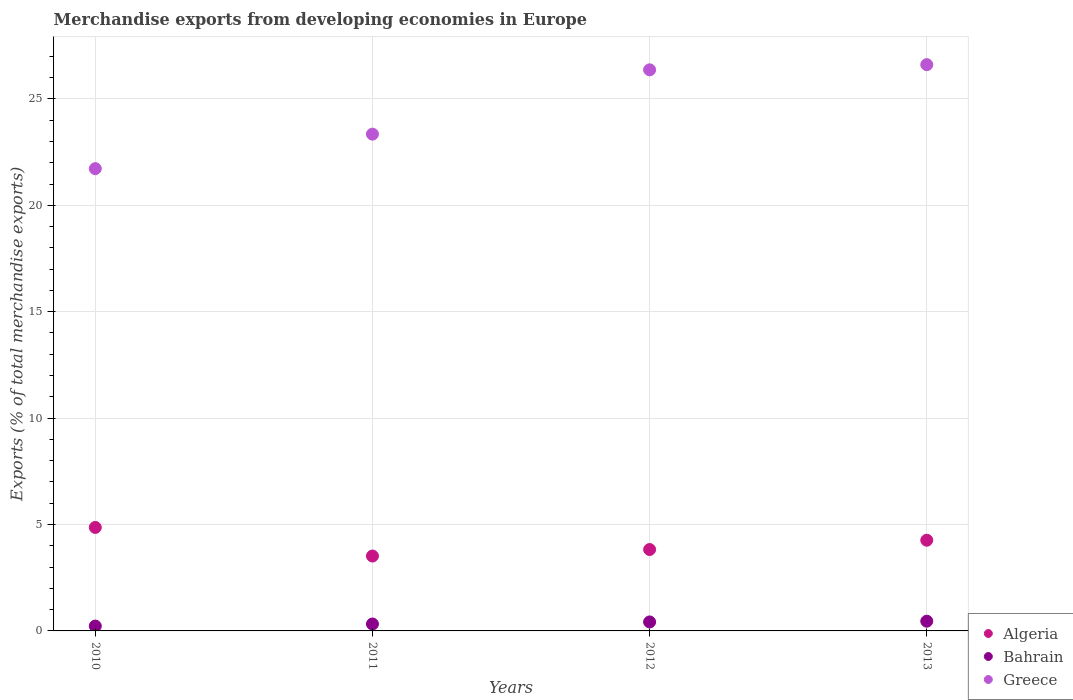How many different coloured dotlines are there?
Keep it short and to the point. 3. Is the number of dotlines equal to the number of legend labels?
Provide a succinct answer. Yes. What is the percentage of total merchandise exports in Greece in 2010?
Ensure brevity in your answer.  21.72. Across all years, what is the maximum percentage of total merchandise exports in Algeria?
Your response must be concise. 4.86. Across all years, what is the minimum percentage of total merchandise exports in Greece?
Provide a succinct answer. 21.72. In which year was the percentage of total merchandise exports in Greece maximum?
Offer a terse response. 2013. In which year was the percentage of total merchandise exports in Bahrain minimum?
Make the answer very short. 2010. What is the total percentage of total merchandise exports in Greece in the graph?
Your answer should be very brief. 98.04. What is the difference between the percentage of total merchandise exports in Greece in 2011 and that in 2012?
Provide a short and direct response. -3.02. What is the difference between the percentage of total merchandise exports in Greece in 2013 and the percentage of total merchandise exports in Bahrain in 2010?
Offer a terse response. 26.38. What is the average percentage of total merchandise exports in Algeria per year?
Provide a succinct answer. 4.12. In the year 2011, what is the difference between the percentage of total merchandise exports in Algeria and percentage of total merchandise exports in Bahrain?
Make the answer very short. 3.19. What is the ratio of the percentage of total merchandise exports in Greece in 2011 to that in 2013?
Your answer should be very brief. 0.88. Is the percentage of total merchandise exports in Bahrain in 2010 less than that in 2013?
Ensure brevity in your answer.  Yes. Is the difference between the percentage of total merchandise exports in Algeria in 2011 and 2013 greater than the difference between the percentage of total merchandise exports in Bahrain in 2011 and 2013?
Keep it short and to the point. No. What is the difference between the highest and the second highest percentage of total merchandise exports in Greece?
Your answer should be very brief. 0.24. What is the difference between the highest and the lowest percentage of total merchandise exports in Algeria?
Offer a terse response. 1.34. In how many years, is the percentage of total merchandise exports in Algeria greater than the average percentage of total merchandise exports in Algeria taken over all years?
Your answer should be very brief. 2. Does the percentage of total merchandise exports in Greece monotonically increase over the years?
Ensure brevity in your answer.  Yes. Is the percentage of total merchandise exports in Algeria strictly greater than the percentage of total merchandise exports in Greece over the years?
Your answer should be compact. No. How many years are there in the graph?
Offer a terse response. 4. Does the graph contain any zero values?
Give a very brief answer. No. Does the graph contain grids?
Your answer should be very brief. Yes. Where does the legend appear in the graph?
Provide a short and direct response. Bottom right. What is the title of the graph?
Offer a terse response. Merchandise exports from developing economies in Europe. Does "Bahrain" appear as one of the legend labels in the graph?
Provide a succinct answer. Yes. What is the label or title of the X-axis?
Ensure brevity in your answer.  Years. What is the label or title of the Y-axis?
Give a very brief answer. Exports (% of total merchandise exports). What is the Exports (% of total merchandise exports) of Algeria in 2010?
Offer a very short reply. 4.86. What is the Exports (% of total merchandise exports) of Bahrain in 2010?
Provide a succinct answer. 0.23. What is the Exports (% of total merchandise exports) in Greece in 2010?
Keep it short and to the point. 21.72. What is the Exports (% of total merchandise exports) in Algeria in 2011?
Your response must be concise. 3.52. What is the Exports (% of total merchandise exports) of Bahrain in 2011?
Offer a terse response. 0.33. What is the Exports (% of total merchandise exports) in Greece in 2011?
Keep it short and to the point. 23.34. What is the Exports (% of total merchandise exports) of Algeria in 2012?
Ensure brevity in your answer.  3.83. What is the Exports (% of total merchandise exports) of Bahrain in 2012?
Make the answer very short. 0.42. What is the Exports (% of total merchandise exports) in Greece in 2012?
Provide a short and direct response. 26.36. What is the Exports (% of total merchandise exports) in Algeria in 2013?
Your answer should be compact. 4.26. What is the Exports (% of total merchandise exports) of Bahrain in 2013?
Your answer should be very brief. 0.46. What is the Exports (% of total merchandise exports) in Greece in 2013?
Provide a short and direct response. 26.61. Across all years, what is the maximum Exports (% of total merchandise exports) of Algeria?
Make the answer very short. 4.86. Across all years, what is the maximum Exports (% of total merchandise exports) of Bahrain?
Keep it short and to the point. 0.46. Across all years, what is the maximum Exports (% of total merchandise exports) of Greece?
Make the answer very short. 26.61. Across all years, what is the minimum Exports (% of total merchandise exports) of Algeria?
Provide a short and direct response. 3.52. Across all years, what is the minimum Exports (% of total merchandise exports) in Bahrain?
Your response must be concise. 0.23. Across all years, what is the minimum Exports (% of total merchandise exports) in Greece?
Offer a very short reply. 21.72. What is the total Exports (% of total merchandise exports) of Algeria in the graph?
Provide a short and direct response. 16.47. What is the total Exports (% of total merchandise exports) in Bahrain in the graph?
Make the answer very short. 1.43. What is the total Exports (% of total merchandise exports) of Greece in the graph?
Offer a very short reply. 98.04. What is the difference between the Exports (% of total merchandise exports) of Algeria in 2010 and that in 2011?
Make the answer very short. 1.34. What is the difference between the Exports (% of total merchandise exports) in Bahrain in 2010 and that in 2011?
Give a very brief answer. -0.1. What is the difference between the Exports (% of total merchandise exports) in Greece in 2010 and that in 2011?
Provide a succinct answer. -1.62. What is the difference between the Exports (% of total merchandise exports) in Algeria in 2010 and that in 2012?
Make the answer very short. 1.04. What is the difference between the Exports (% of total merchandise exports) of Bahrain in 2010 and that in 2012?
Make the answer very short. -0.19. What is the difference between the Exports (% of total merchandise exports) of Greece in 2010 and that in 2012?
Your answer should be very brief. -4.64. What is the difference between the Exports (% of total merchandise exports) in Algeria in 2010 and that in 2013?
Your answer should be very brief. 0.6. What is the difference between the Exports (% of total merchandise exports) of Bahrain in 2010 and that in 2013?
Ensure brevity in your answer.  -0.23. What is the difference between the Exports (% of total merchandise exports) of Greece in 2010 and that in 2013?
Make the answer very short. -4.89. What is the difference between the Exports (% of total merchandise exports) of Algeria in 2011 and that in 2012?
Provide a short and direct response. -0.31. What is the difference between the Exports (% of total merchandise exports) in Bahrain in 2011 and that in 2012?
Give a very brief answer. -0.1. What is the difference between the Exports (% of total merchandise exports) in Greece in 2011 and that in 2012?
Offer a terse response. -3.02. What is the difference between the Exports (% of total merchandise exports) of Algeria in 2011 and that in 2013?
Keep it short and to the point. -0.74. What is the difference between the Exports (% of total merchandise exports) in Bahrain in 2011 and that in 2013?
Make the answer very short. -0.13. What is the difference between the Exports (% of total merchandise exports) in Greece in 2011 and that in 2013?
Your answer should be very brief. -3.27. What is the difference between the Exports (% of total merchandise exports) in Algeria in 2012 and that in 2013?
Offer a terse response. -0.44. What is the difference between the Exports (% of total merchandise exports) in Bahrain in 2012 and that in 2013?
Keep it short and to the point. -0.03. What is the difference between the Exports (% of total merchandise exports) in Greece in 2012 and that in 2013?
Make the answer very short. -0.24. What is the difference between the Exports (% of total merchandise exports) of Algeria in 2010 and the Exports (% of total merchandise exports) of Bahrain in 2011?
Provide a succinct answer. 4.54. What is the difference between the Exports (% of total merchandise exports) in Algeria in 2010 and the Exports (% of total merchandise exports) in Greece in 2011?
Offer a very short reply. -18.48. What is the difference between the Exports (% of total merchandise exports) of Bahrain in 2010 and the Exports (% of total merchandise exports) of Greece in 2011?
Give a very brief answer. -23.11. What is the difference between the Exports (% of total merchandise exports) of Algeria in 2010 and the Exports (% of total merchandise exports) of Bahrain in 2012?
Your response must be concise. 4.44. What is the difference between the Exports (% of total merchandise exports) of Algeria in 2010 and the Exports (% of total merchandise exports) of Greece in 2012?
Provide a short and direct response. -21.5. What is the difference between the Exports (% of total merchandise exports) of Bahrain in 2010 and the Exports (% of total merchandise exports) of Greece in 2012?
Ensure brevity in your answer.  -26.14. What is the difference between the Exports (% of total merchandise exports) of Algeria in 2010 and the Exports (% of total merchandise exports) of Bahrain in 2013?
Offer a terse response. 4.41. What is the difference between the Exports (% of total merchandise exports) of Algeria in 2010 and the Exports (% of total merchandise exports) of Greece in 2013?
Ensure brevity in your answer.  -21.75. What is the difference between the Exports (% of total merchandise exports) of Bahrain in 2010 and the Exports (% of total merchandise exports) of Greece in 2013?
Offer a very short reply. -26.38. What is the difference between the Exports (% of total merchandise exports) in Algeria in 2011 and the Exports (% of total merchandise exports) in Bahrain in 2012?
Keep it short and to the point. 3.1. What is the difference between the Exports (% of total merchandise exports) of Algeria in 2011 and the Exports (% of total merchandise exports) of Greece in 2012?
Keep it short and to the point. -22.85. What is the difference between the Exports (% of total merchandise exports) in Bahrain in 2011 and the Exports (% of total merchandise exports) in Greece in 2012?
Your answer should be compact. -26.04. What is the difference between the Exports (% of total merchandise exports) in Algeria in 2011 and the Exports (% of total merchandise exports) in Bahrain in 2013?
Offer a very short reply. 3.06. What is the difference between the Exports (% of total merchandise exports) in Algeria in 2011 and the Exports (% of total merchandise exports) in Greece in 2013?
Your response must be concise. -23.09. What is the difference between the Exports (% of total merchandise exports) of Bahrain in 2011 and the Exports (% of total merchandise exports) of Greece in 2013?
Make the answer very short. -26.28. What is the difference between the Exports (% of total merchandise exports) in Algeria in 2012 and the Exports (% of total merchandise exports) in Bahrain in 2013?
Keep it short and to the point. 3.37. What is the difference between the Exports (% of total merchandise exports) in Algeria in 2012 and the Exports (% of total merchandise exports) in Greece in 2013?
Ensure brevity in your answer.  -22.78. What is the difference between the Exports (% of total merchandise exports) in Bahrain in 2012 and the Exports (% of total merchandise exports) in Greece in 2013?
Provide a short and direct response. -26.19. What is the average Exports (% of total merchandise exports) in Algeria per year?
Make the answer very short. 4.12. What is the average Exports (% of total merchandise exports) of Bahrain per year?
Ensure brevity in your answer.  0.36. What is the average Exports (% of total merchandise exports) in Greece per year?
Give a very brief answer. 24.51. In the year 2010, what is the difference between the Exports (% of total merchandise exports) of Algeria and Exports (% of total merchandise exports) of Bahrain?
Your response must be concise. 4.63. In the year 2010, what is the difference between the Exports (% of total merchandise exports) of Algeria and Exports (% of total merchandise exports) of Greece?
Your answer should be very brief. -16.86. In the year 2010, what is the difference between the Exports (% of total merchandise exports) of Bahrain and Exports (% of total merchandise exports) of Greece?
Ensure brevity in your answer.  -21.49. In the year 2011, what is the difference between the Exports (% of total merchandise exports) of Algeria and Exports (% of total merchandise exports) of Bahrain?
Offer a terse response. 3.19. In the year 2011, what is the difference between the Exports (% of total merchandise exports) in Algeria and Exports (% of total merchandise exports) in Greece?
Give a very brief answer. -19.82. In the year 2011, what is the difference between the Exports (% of total merchandise exports) in Bahrain and Exports (% of total merchandise exports) in Greece?
Keep it short and to the point. -23.02. In the year 2012, what is the difference between the Exports (% of total merchandise exports) of Algeria and Exports (% of total merchandise exports) of Bahrain?
Your response must be concise. 3.4. In the year 2012, what is the difference between the Exports (% of total merchandise exports) of Algeria and Exports (% of total merchandise exports) of Greece?
Your response must be concise. -22.54. In the year 2012, what is the difference between the Exports (% of total merchandise exports) of Bahrain and Exports (% of total merchandise exports) of Greece?
Offer a very short reply. -25.94. In the year 2013, what is the difference between the Exports (% of total merchandise exports) in Algeria and Exports (% of total merchandise exports) in Bahrain?
Provide a short and direct response. 3.81. In the year 2013, what is the difference between the Exports (% of total merchandise exports) of Algeria and Exports (% of total merchandise exports) of Greece?
Your answer should be compact. -22.35. In the year 2013, what is the difference between the Exports (% of total merchandise exports) in Bahrain and Exports (% of total merchandise exports) in Greece?
Provide a short and direct response. -26.15. What is the ratio of the Exports (% of total merchandise exports) in Algeria in 2010 to that in 2011?
Offer a terse response. 1.38. What is the ratio of the Exports (% of total merchandise exports) in Bahrain in 2010 to that in 2011?
Provide a succinct answer. 0.7. What is the ratio of the Exports (% of total merchandise exports) in Greece in 2010 to that in 2011?
Keep it short and to the point. 0.93. What is the ratio of the Exports (% of total merchandise exports) of Algeria in 2010 to that in 2012?
Provide a succinct answer. 1.27. What is the ratio of the Exports (% of total merchandise exports) of Bahrain in 2010 to that in 2012?
Your answer should be very brief. 0.54. What is the ratio of the Exports (% of total merchandise exports) in Greece in 2010 to that in 2012?
Provide a succinct answer. 0.82. What is the ratio of the Exports (% of total merchandise exports) in Algeria in 2010 to that in 2013?
Your answer should be compact. 1.14. What is the ratio of the Exports (% of total merchandise exports) in Bahrain in 2010 to that in 2013?
Give a very brief answer. 0.5. What is the ratio of the Exports (% of total merchandise exports) in Greece in 2010 to that in 2013?
Make the answer very short. 0.82. What is the ratio of the Exports (% of total merchandise exports) of Algeria in 2011 to that in 2012?
Ensure brevity in your answer.  0.92. What is the ratio of the Exports (% of total merchandise exports) of Bahrain in 2011 to that in 2012?
Your answer should be compact. 0.77. What is the ratio of the Exports (% of total merchandise exports) of Greece in 2011 to that in 2012?
Make the answer very short. 0.89. What is the ratio of the Exports (% of total merchandise exports) in Algeria in 2011 to that in 2013?
Offer a very short reply. 0.83. What is the ratio of the Exports (% of total merchandise exports) of Bahrain in 2011 to that in 2013?
Ensure brevity in your answer.  0.71. What is the ratio of the Exports (% of total merchandise exports) of Greece in 2011 to that in 2013?
Your answer should be very brief. 0.88. What is the ratio of the Exports (% of total merchandise exports) in Algeria in 2012 to that in 2013?
Provide a short and direct response. 0.9. What is the ratio of the Exports (% of total merchandise exports) in Bahrain in 2012 to that in 2013?
Make the answer very short. 0.92. What is the ratio of the Exports (% of total merchandise exports) in Greece in 2012 to that in 2013?
Keep it short and to the point. 0.99. What is the difference between the highest and the second highest Exports (% of total merchandise exports) in Algeria?
Give a very brief answer. 0.6. What is the difference between the highest and the second highest Exports (% of total merchandise exports) of Bahrain?
Provide a short and direct response. 0.03. What is the difference between the highest and the second highest Exports (% of total merchandise exports) in Greece?
Your answer should be compact. 0.24. What is the difference between the highest and the lowest Exports (% of total merchandise exports) of Algeria?
Your response must be concise. 1.34. What is the difference between the highest and the lowest Exports (% of total merchandise exports) of Bahrain?
Offer a very short reply. 0.23. What is the difference between the highest and the lowest Exports (% of total merchandise exports) in Greece?
Give a very brief answer. 4.89. 